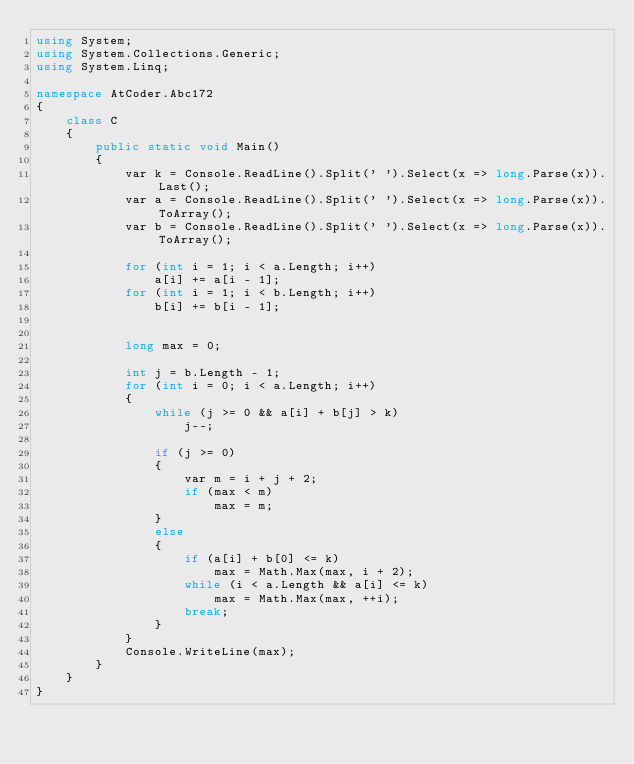Convert code to text. <code><loc_0><loc_0><loc_500><loc_500><_C#_>using System;
using System.Collections.Generic;
using System.Linq;

namespace AtCoder.Abc172
{
    class C
    {
        public static void Main()
        {
            var k = Console.ReadLine().Split(' ').Select(x => long.Parse(x)).Last();
            var a = Console.ReadLine().Split(' ').Select(x => long.Parse(x)).ToArray();
            var b = Console.ReadLine().Split(' ').Select(x => long.Parse(x)).ToArray();

            for (int i = 1; i < a.Length; i++)
                a[i] += a[i - 1];
            for (int i = 1; i < b.Length; i++)
                b[i] += b[i - 1];


            long max = 0;

            int j = b.Length - 1;
            for (int i = 0; i < a.Length; i++)
            {
                while (j >= 0 && a[i] + b[j] > k)
                    j--;

                if (j >= 0)
                {
                    var m = i + j + 2;
                    if (max < m)
                        max = m;
                }
                else
                {
                    if (a[i] + b[0] <= k)
                        max = Math.Max(max, i + 2);
                    while (i < a.Length && a[i] <= k)
                        max = Math.Max(max, ++i);
                    break;
                }
            }
            Console.WriteLine(max);
        }
    }
}
</code> 